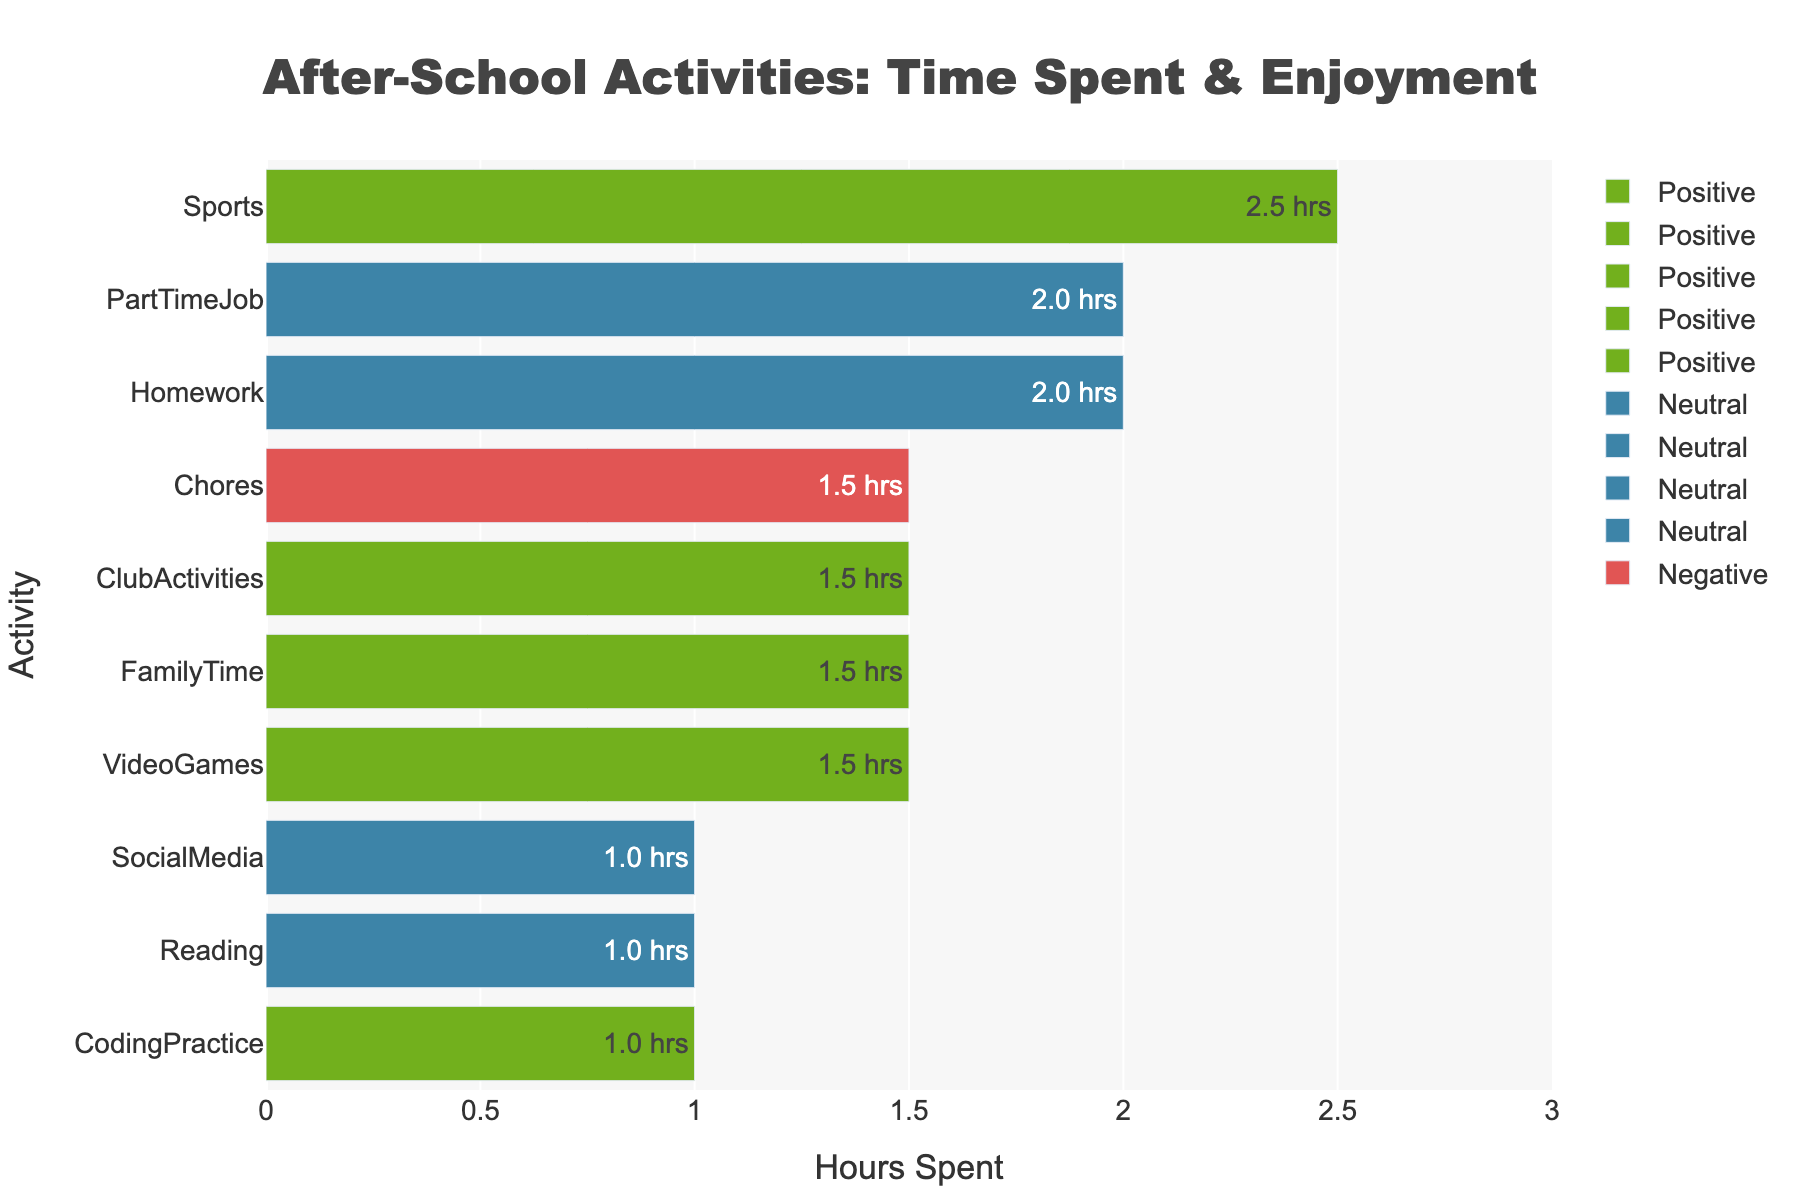What activity do I spend the most time on after school? Look for the activity with the longest bar. Sports has the longest bar, indicating the highest hours spent.
Answer: Sports Which activities are associated with a Positive enjoyment level? Identify the activities characterized by green bars. CodingPractice, VideoGames, Sports, FamilyTime, and ClubActivities are all green, indicating Positive enjoyment.
Answer: CodingPractice, VideoGames, Sports, FamilyTime, ClubActivities How many hours do I spend on activities I enjoy positively? Sum up the hours for the activities with Positive enjoyment. Adding 1 (CodingPractice), 1.5 (VideoGames), 2.5 (Sports), 1.5 (FamilyTime), and 1.5 (ClubActivities) gives 8 hours.
Answer: 8 hours Which activity has the lowest enjoyment level and how much time is spent on it? Identify the activity with a red bar and note its length. Chores is red, with a length of 1.5 hours.
Answer: Chores, 1.5 hours How do the total hours spent on neutral activities compare to those spent on positive activities? Sum the hours for Neutral activities (2 (Homework) + 1 (Reading) + 2 (PartTimeJob) + 1 (SocialMedia)) = 6 hours. For Positive activities, it is 8 hours as calculated previously. 6 hours for Neutral activities is less than 8 hours for Positive activities.
Answer: 6 hours vs. 8 hours; Neutral is less than Positive Which activity has an equal amount of hours spent as FamilyTime? FamilyTime has 1.5 hours. Identify other activities with the same bar length. VideoGames and ClubActivities also have 1.5 hours.
Answer: VideoGames, ClubActivities By how much do hours spent on sports exceed those for chores? Sports has 2.5 hours, and chores have 1.5 hours. The difference is 2.5 - 1.5 = 1 hour.
Answer: 1 hour What is the average time spent on neutral activities? Sum the hours for neutral activities (6 hours) and divide by the number of neutral activities (4: Homework, Reading, PartTimeJob, and SocialMedia). 6 / 4 = 1.5 hours.
Answer: 1.5 hours 